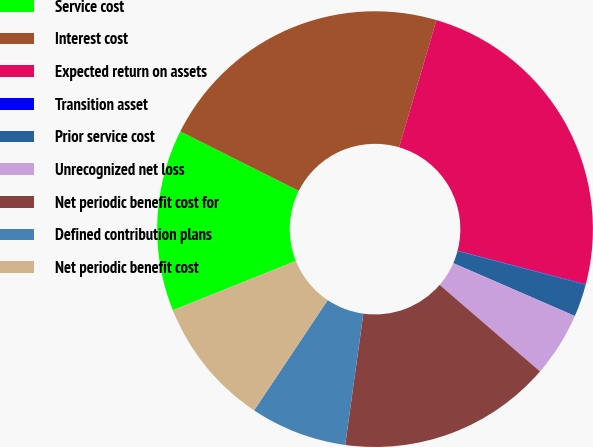Convert chart. <chart><loc_0><loc_0><loc_500><loc_500><pie_chart><fcel>Service cost<fcel>Interest cost<fcel>Expected return on assets<fcel>Transition asset<fcel>Prior service cost<fcel>Unrecognized net loss<fcel>Net periodic benefit cost for<fcel>Defined contribution plans<fcel>Net periodic benefit cost<nl><fcel>13.48%<fcel>22.14%<fcel>24.52%<fcel>0.04%<fcel>2.42%<fcel>4.8%<fcel>15.86%<fcel>7.18%<fcel>9.56%<nl></chart> 